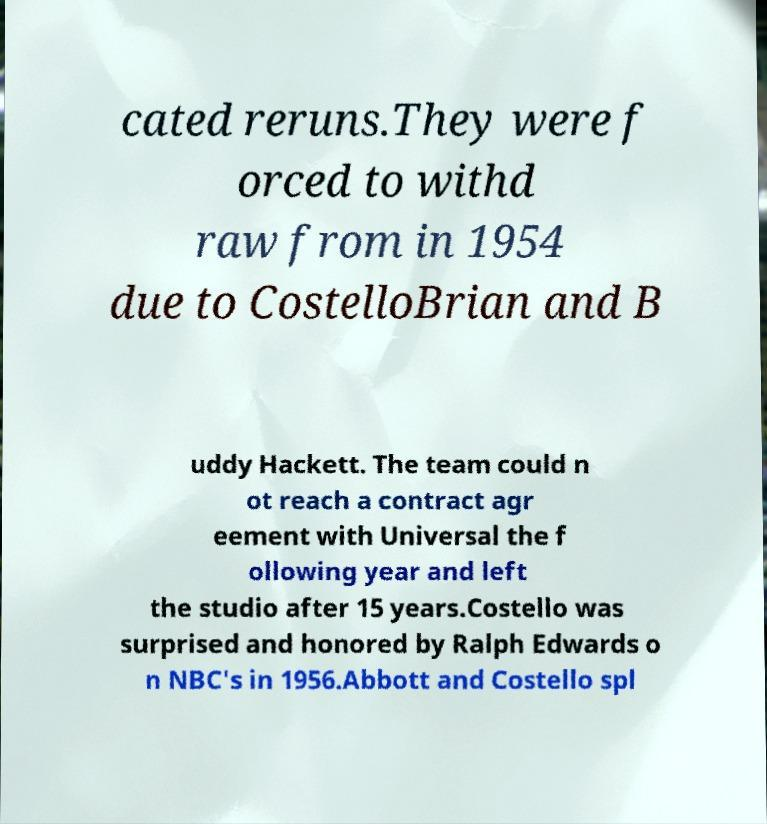Could you extract and type out the text from this image? cated reruns.They were f orced to withd raw from in 1954 due to CostelloBrian and B uddy Hackett. The team could n ot reach a contract agr eement with Universal the f ollowing year and left the studio after 15 years.Costello was surprised and honored by Ralph Edwards o n NBC's in 1956.Abbott and Costello spl 